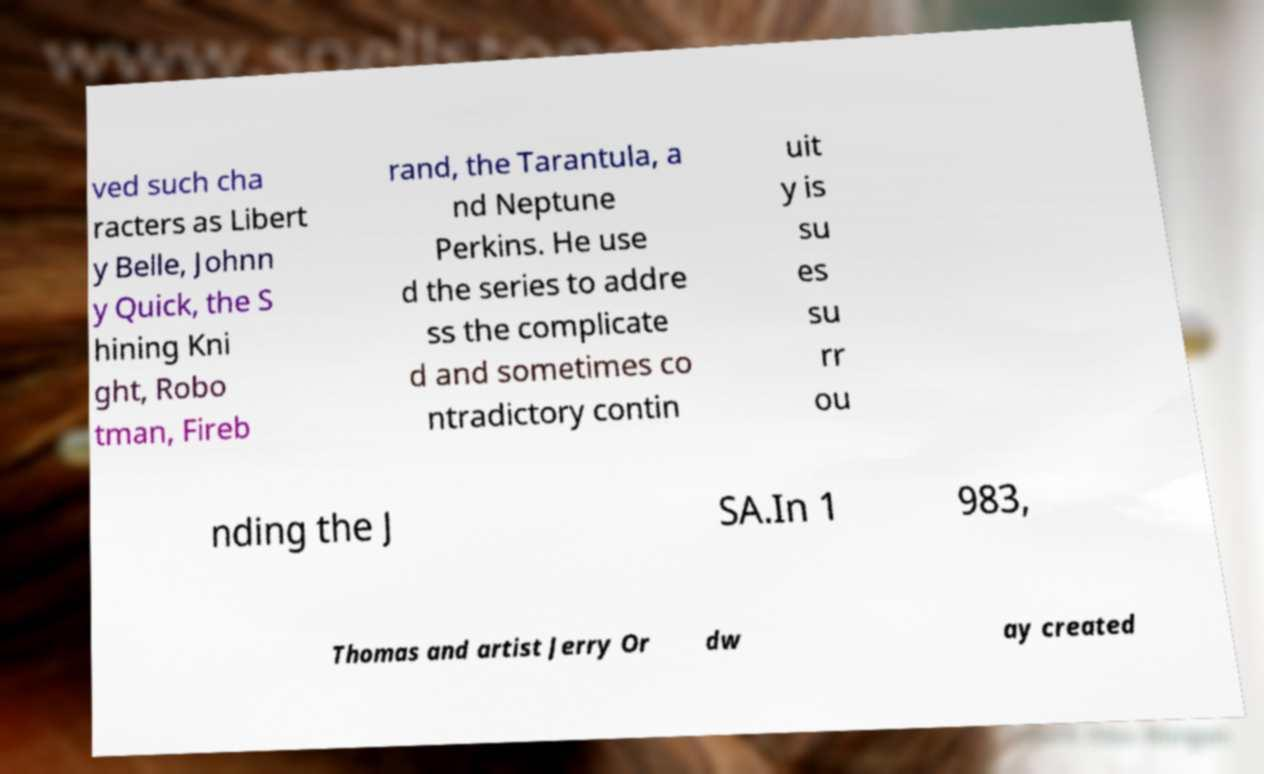For documentation purposes, I need the text within this image transcribed. Could you provide that? ved such cha racters as Libert y Belle, Johnn y Quick, the S hining Kni ght, Robo tman, Fireb rand, the Tarantula, a nd Neptune Perkins. He use d the series to addre ss the complicate d and sometimes co ntradictory contin uit y is su es su rr ou nding the J SA.In 1 983, Thomas and artist Jerry Or dw ay created 